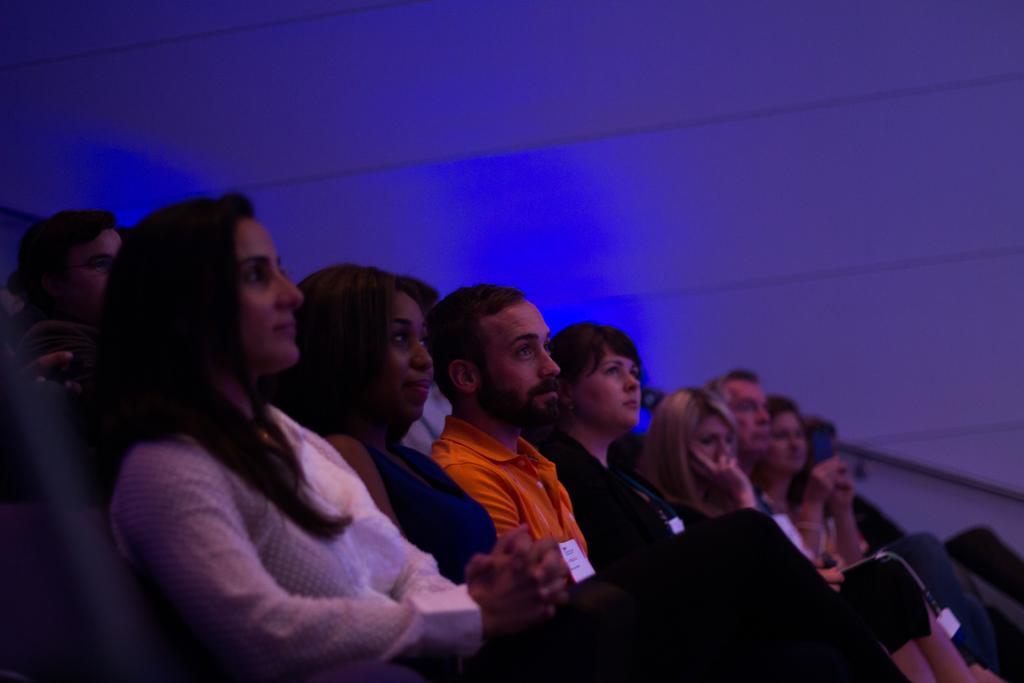How would you summarize this image in a sentence or two? In this picture there are people sitting. In the background of the image we can see wall and rod. 